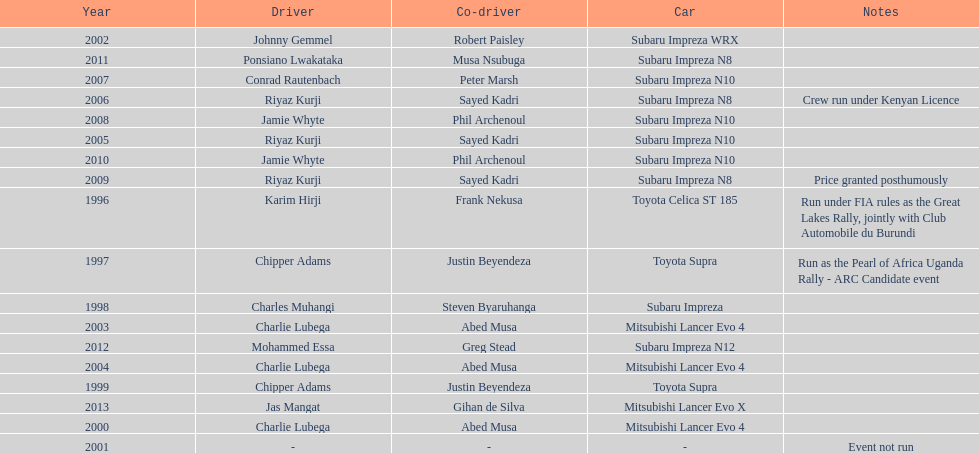Do chipper adams and justin beyendeza have more than 3 wins? No. Parse the table in full. {'header': ['Year', 'Driver', 'Co-driver', 'Car', 'Notes'], 'rows': [['2002', 'Johnny Gemmel', 'Robert Paisley', 'Subaru Impreza WRX', ''], ['2011', 'Ponsiano Lwakataka', 'Musa Nsubuga', 'Subaru Impreza N8', ''], ['2007', 'Conrad Rautenbach', 'Peter Marsh', 'Subaru Impreza N10', ''], ['2006', 'Riyaz Kurji', 'Sayed Kadri', 'Subaru Impreza N8', 'Crew run under Kenyan Licence'], ['2008', 'Jamie Whyte', 'Phil Archenoul', 'Subaru Impreza N10', ''], ['2005', 'Riyaz Kurji', 'Sayed Kadri', 'Subaru Impreza N10', ''], ['2010', 'Jamie Whyte', 'Phil Archenoul', 'Subaru Impreza N10', ''], ['2009', 'Riyaz Kurji', 'Sayed Kadri', 'Subaru Impreza N8', 'Price granted posthumously'], ['1996', 'Karim Hirji', 'Frank Nekusa', 'Toyota Celica ST 185', 'Run under FIA rules as the Great Lakes Rally, jointly with Club Automobile du Burundi'], ['1997', 'Chipper Adams', 'Justin Beyendeza', 'Toyota Supra', 'Run as the Pearl of Africa Uganda Rally - ARC Candidate event'], ['1998', 'Charles Muhangi', 'Steven Byaruhanga', 'Subaru Impreza', ''], ['2003', 'Charlie Lubega', 'Abed Musa', 'Mitsubishi Lancer Evo 4', ''], ['2012', 'Mohammed Essa', 'Greg Stead', 'Subaru Impreza N12', ''], ['2004', 'Charlie Lubega', 'Abed Musa', 'Mitsubishi Lancer Evo 4', ''], ['1999', 'Chipper Adams', 'Justin Beyendeza', 'Toyota Supra', ''], ['2013', 'Jas Mangat', 'Gihan de Silva', 'Mitsubishi Lancer Evo X', ''], ['2000', 'Charlie Lubega', 'Abed Musa', 'Mitsubishi Lancer Evo 4', ''], ['2001', '-', '-', '-', 'Event not run']]} 